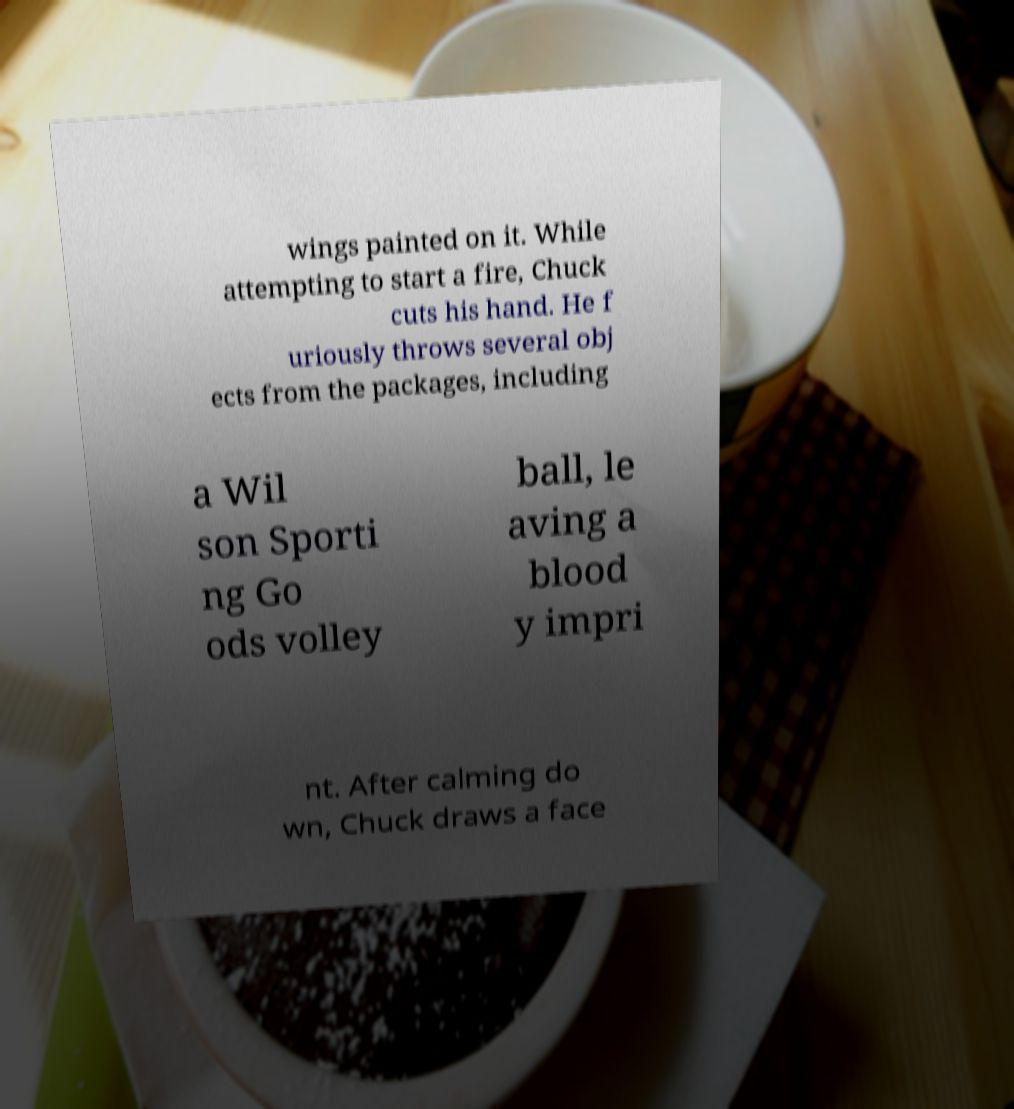Please read and relay the text visible in this image. What does it say? wings painted on it. While attempting to start a fire, Chuck cuts his hand. He f uriously throws several obj ects from the packages, including a Wil son Sporti ng Go ods volley ball, le aving a blood y impri nt. After calming do wn, Chuck draws a face 